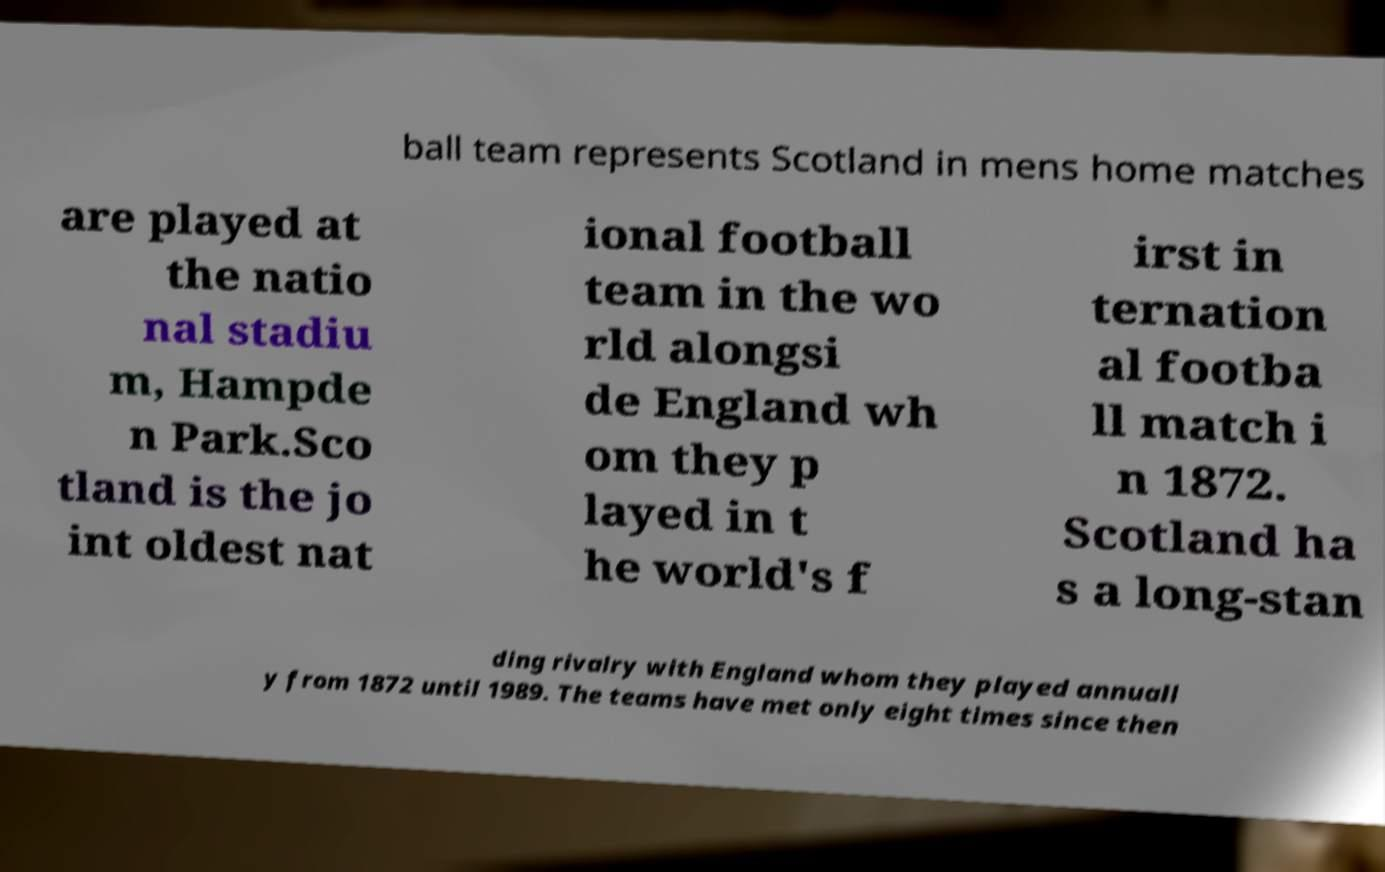There's text embedded in this image that I need extracted. Can you transcribe it verbatim? ball team represents Scotland in mens home matches are played at the natio nal stadiu m, Hampde n Park.Sco tland is the jo int oldest nat ional football team in the wo rld alongsi de England wh om they p layed in t he world's f irst in ternation al footba ll match i n 1872. Scotland ha s a long-stan ding rivalry with England whom they played annuall y from 1872 until 1989. The teams have met only eight times since then 